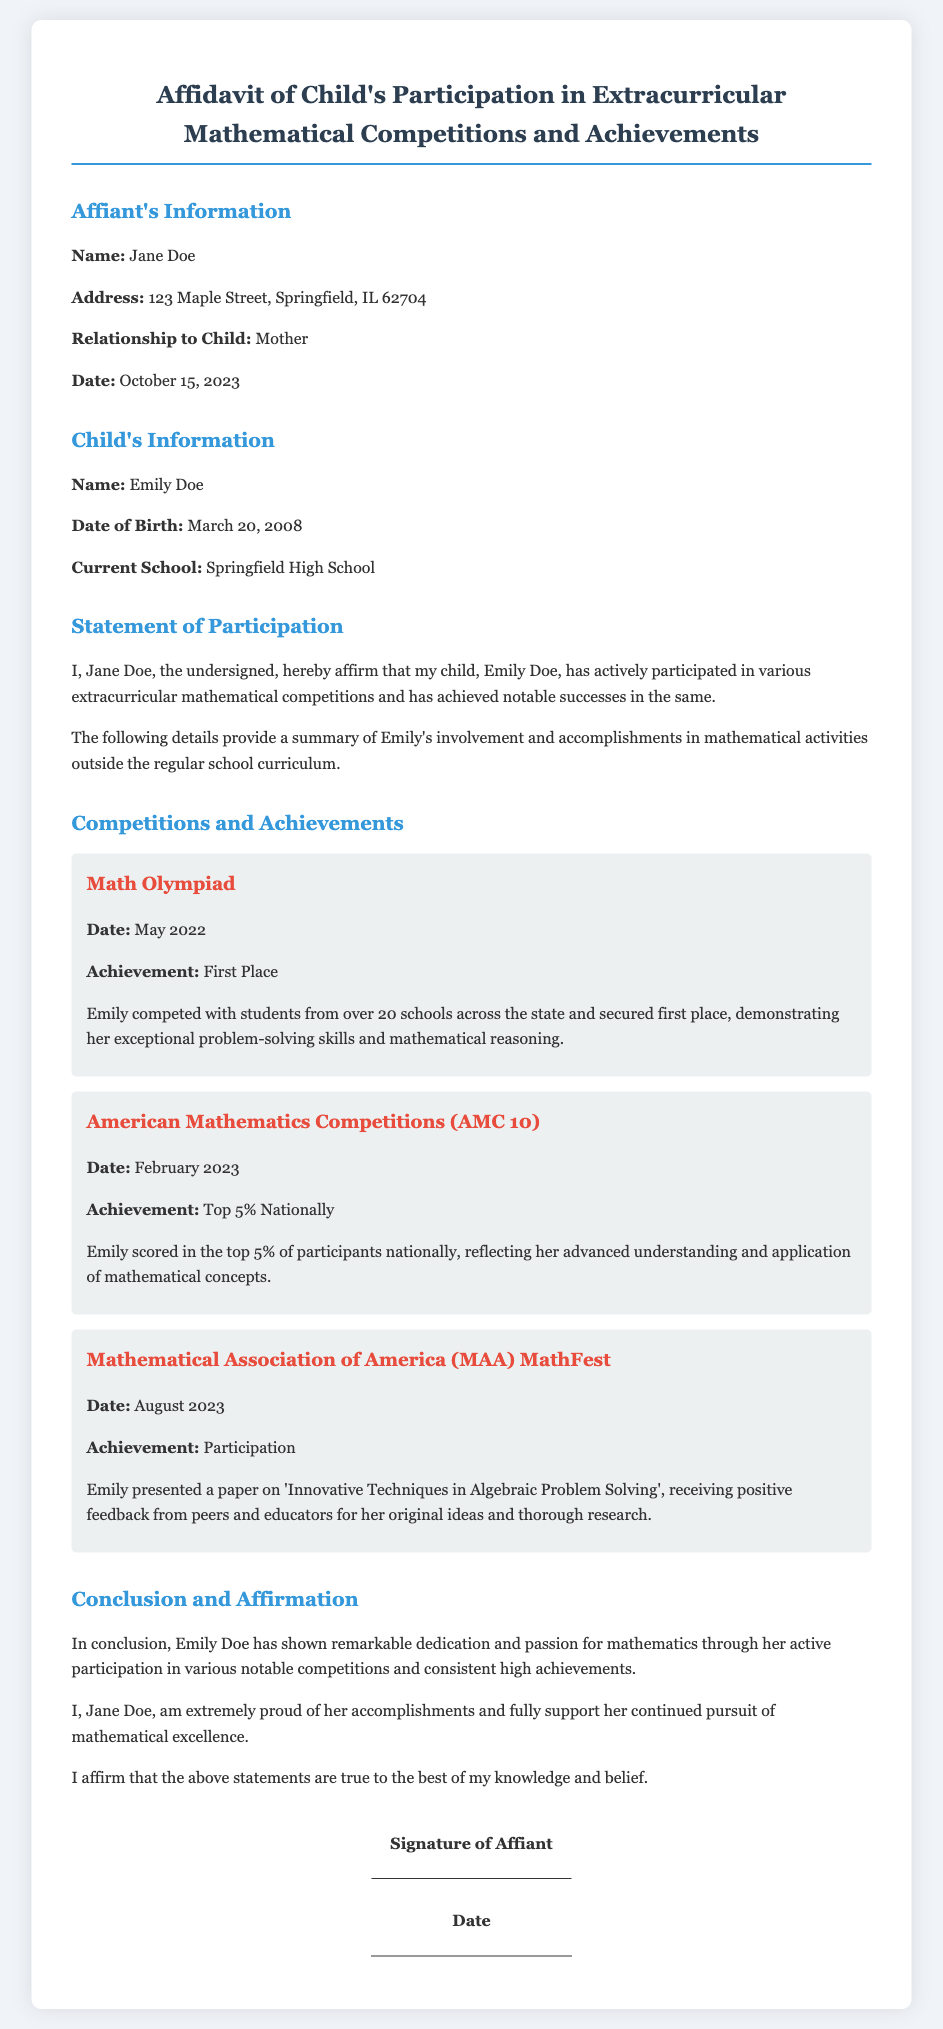What is the name of the affiant? The affiant's name is provided in the document as Jane Doe.
Answer: Jane Doe What is Emily's date of birth? The date of birth for Emily is listed as March 20, 2008.
Answer: March 20, 2008 What competition did Emily achieve first place in? The document states that Emily secured first place in the Math Olympiad.
Answer: Math Olympiad What percentage did Emily score in the American Mathematics Competitions? The document indicates Emily scored in the top 5% nationally in the AMC 10.
Answer: Top 5% Nationally What was the topic of Emily's paper presented at MathFest? The document mentions the topic of Emily's paper as 'Innovative Techniques in Algebraic Problem Solving'.
Answer: Innovative Techniques in Algebraic Problem Solving What is the relationship of the affiant to the child? The document specifies that the affiant is the mother of the child.
Answer: Mother What is the current school of Emily? The current school mentioned for Emily in the document is Springfield High School.
Answer: Springfield High School What month and year did Emily participate in the MAA MathFest? The month and year of Emily's participation in MathFest is August 2023.
Answer: August 2023 